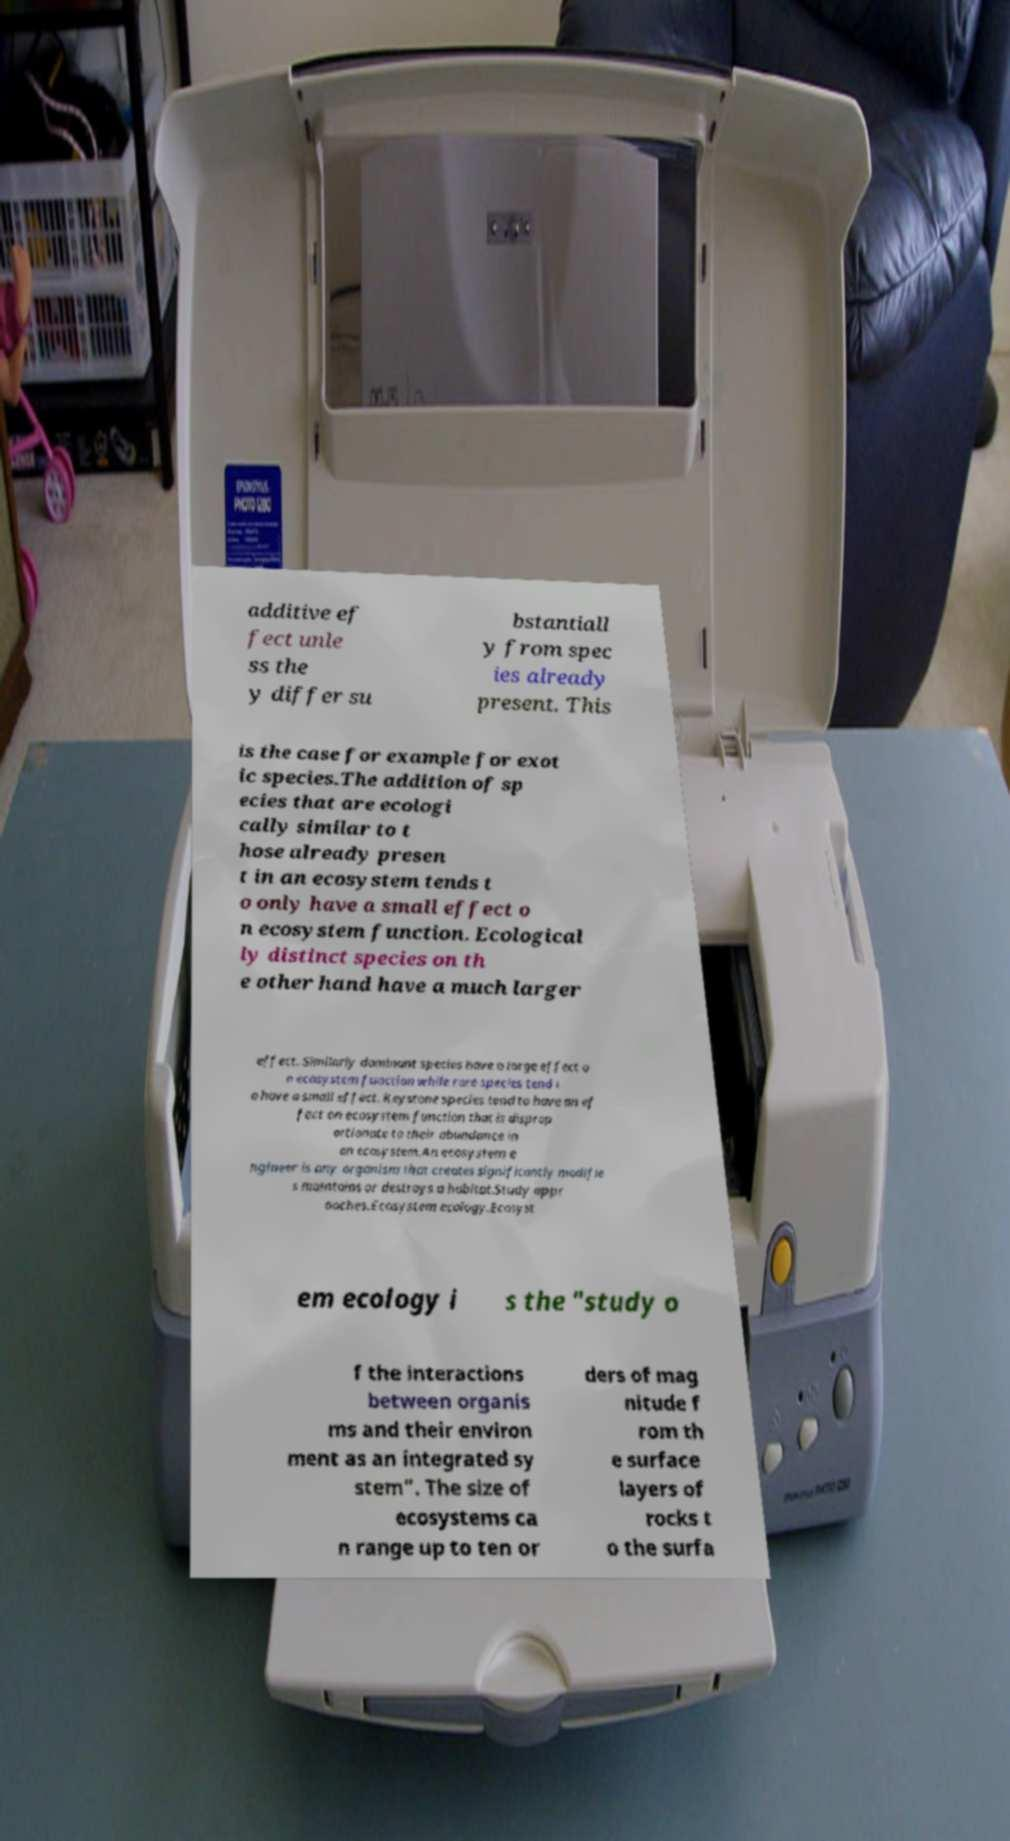What messages or text are displayed in this image? I need them in a readable, typed format. additive ef fect unle ss the y differ su bstantiall y from spec ies already present. This is the case for example for exot ic species.The addition of sp ecies that are ecologi cally similar to t hose already presen t in an ecosystem tends t o only have a small effect o n ecosystem function. Ecological ly distinct species on th e other hand have a much larger effect. Similarly dominant species have a large effect o n ecosystem function while rare species tend t o have a small effect. Keystone species tend to have an ef fect on ecosystem function that is disprop ortionate to their abundance in an ecosystem.An ecosystem e ngineer is any organism that creates significantly modifie s maintains or destroys a habitat.Study appr oaches.Ecosystem ecology.Ecosyst em ecology i s the "study o f the interactions between organis ms and their environ ment as an integrated sy stem". The size of ecosystems ca n range up to ten or ders of mag nitude f rom th e surface layers of rocks t o the surfa 